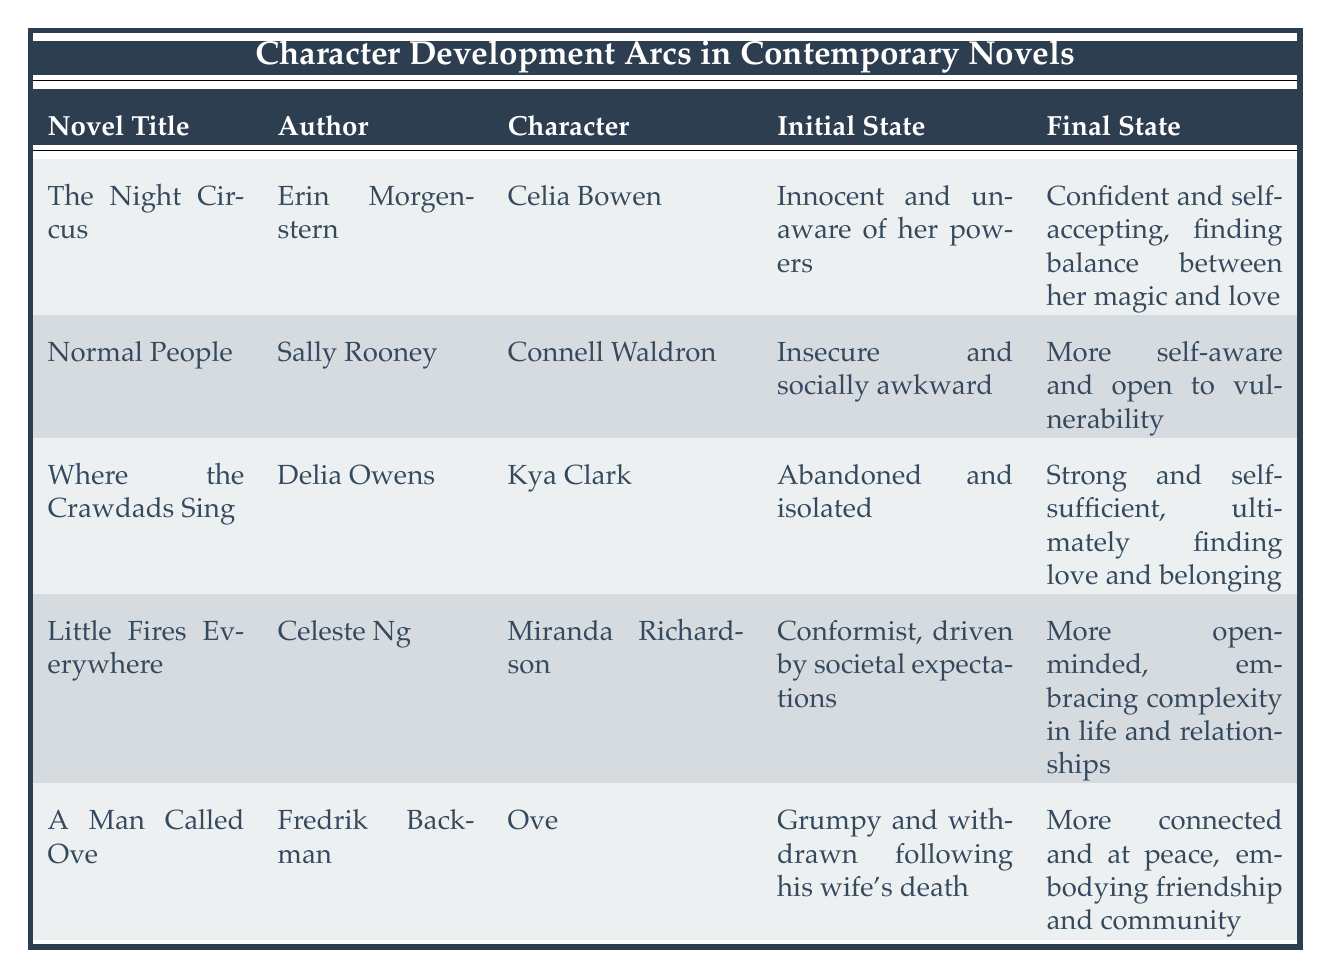What is the initial state of Celia Bowen in "The Night Circus"? The initial state of Celia Bowen is "Innocent and unaware of her powers," as stated in the table under her character information.
Answer: Innocent and unaware of her powers Which character transforms from "Abandoned and isolated" to "Strong and self-sufficient"? Kya Clark from "Where the Crawdads Sing" undergoes this transformation, as reflected in the specific entries for her character in the table.
Answer: Kya Clark Is Miranda Richardson described as a conformist before her transformation? Yes, the table states that Miranda Richardson's initial state is "Conformist, driven by societal expectations," confirming this fact.
Answer: Yes What do the final states of characters in this table suggest about their development? The final states show that each character has moved towards a more positive, self-aware, or connected state, illustrating successful character development or personal growth through their respective arcs.
Answer: They illustrate personal growth Which author has a character that becomes more open to vulnerability? Sally Rooney is the author of Connell Waldron, who is described as becoming "More self-aware and open to vulnerability," as per the details in the table.
Answer: Sally Rooney 